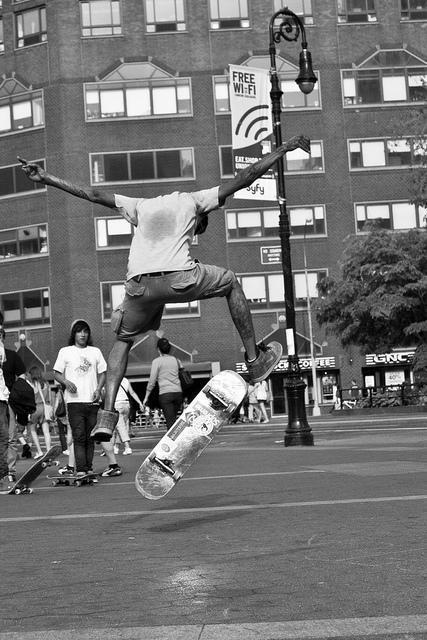What type of goods are sold in the store next to the tree?
Answer the question by selecting the correct answer among the 4 following choices.
Options: Baked goods, coffee, nutritional supplements, pizza. Nutritional supplements. 